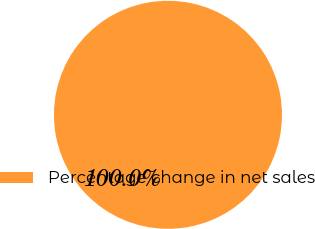Convert chart to OTSL. <chart><loc_0><loc_0><loc_500><loc_500><pie_chart><fcel>Percentage change in net sales<nl><fcel>100.0%<nl></chart> 